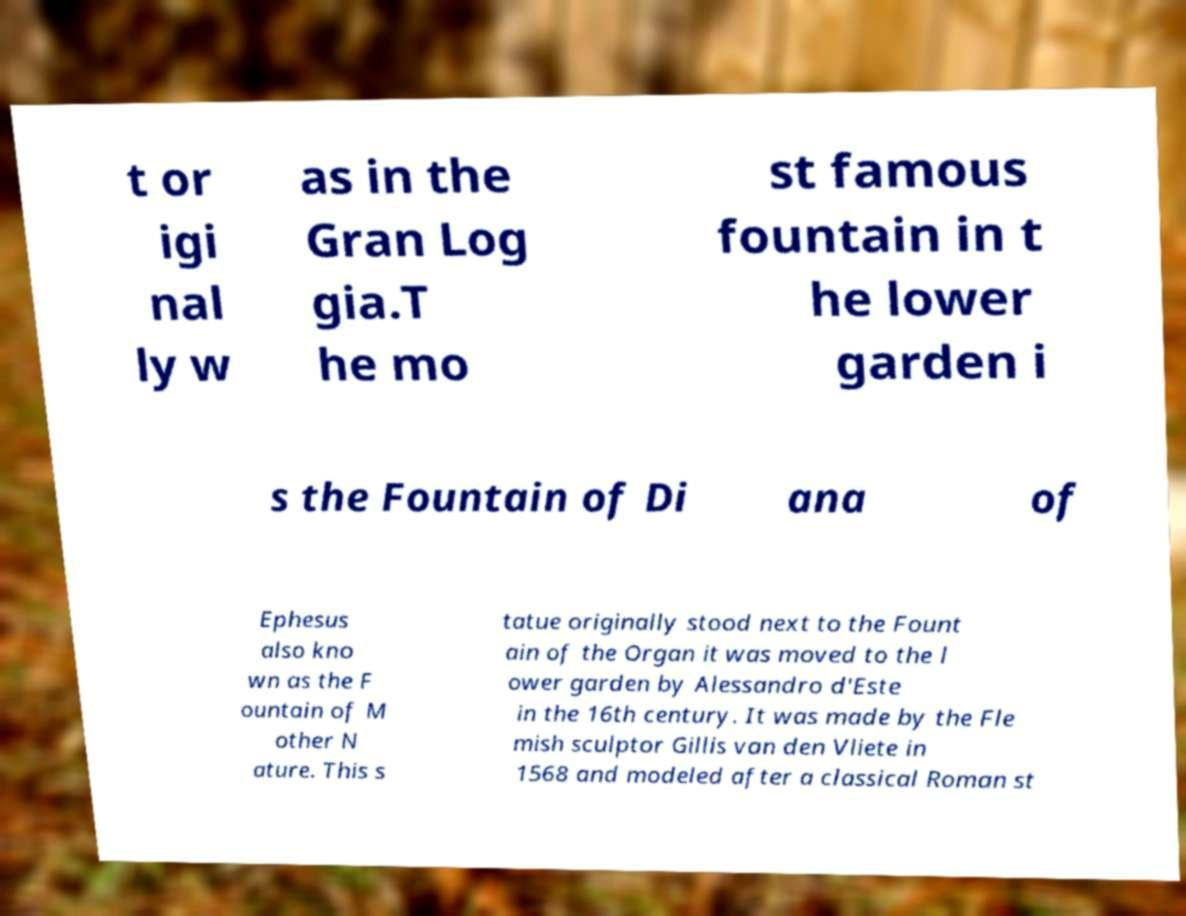Can you read and provide the text displayed in the image?This photo seems to have some interesting text. Can you extract and type it out for me? t or igi nal ly w as in the Gran Log gia.T he mo st famous fountain in t he lower garden i s the Fountain of Di ana of Ephesus also kno wn as the F ountain of M other N ature. This s tatue originally stood next to the Fount ain of the Organ it was moved to the l ower garden by Alessandro d'Este in the 16th century. It was made by the Fle mish sculptor Gillis van den Vliete in 1568 and modeled after a classical Roman st 